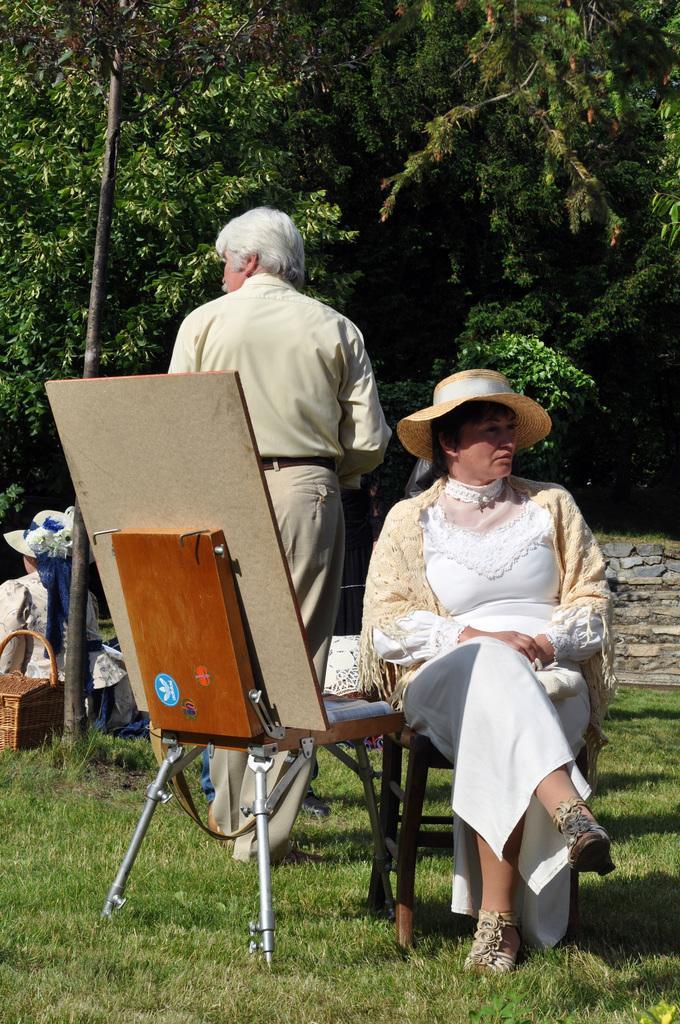Could you give a brief overview of what you see in this image? There is a woman sitting on the chair behind her a man is standing and a woman is sitting at the pole and we can also see trees in the background. 